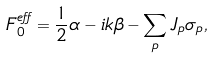Convert formula to latex. <formula><loc_0><loc_0><loc_500><loc_500>F _ { 0 } ^ { e f f } = \frac { 1 } { 2 } \alpha - i k \beta - \sum _ { p } J _ { p } \sigma _ { p } ,</formula> 